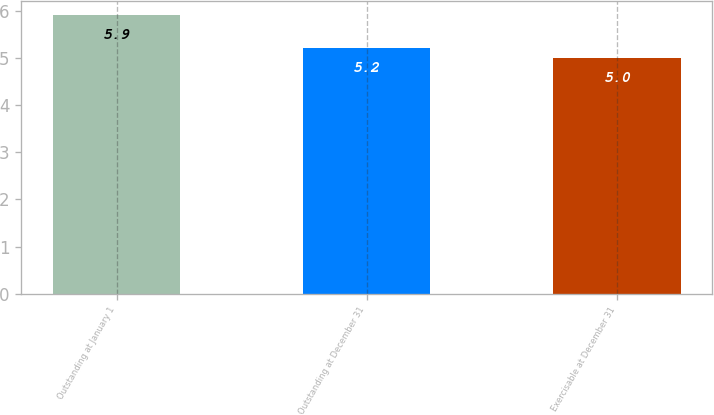Convert chart to OTSL. <chart><loc_0><loc_0><loc_500><loc_500><bar_chart><fcel>Outstanding at January 1<fcel>Outstanding at December 31<fcel>Exercisable at December 31<nl><fcel>5.9<fcel>5.2<fcel>5<nl></chart> 